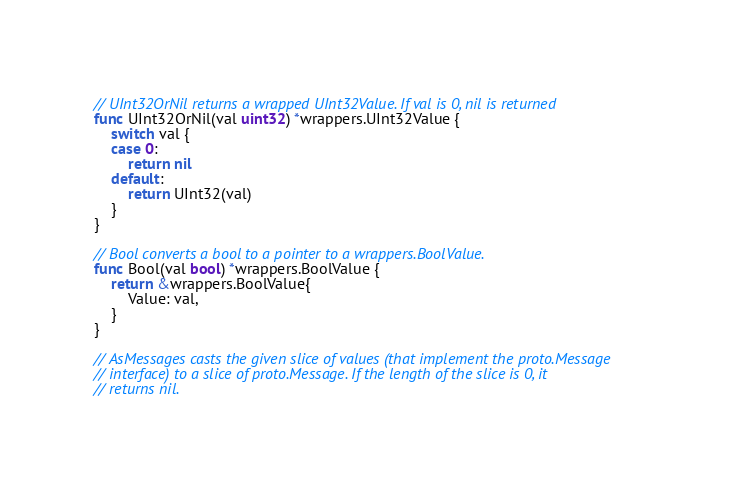Convert code to text. <code><loc_0><loc_0><loc_500><loc_500><_Go_>// UInt32OrNil returns a wrapped UInt32Value. If val is 0, nil is returned
func UInt32OrNil(val uint32) *wrappers.UInt32Value {
	switch val {
	case 0:
		return nil
	default:
		return UInt32(val)
	}
}

// Bool converts a bool to a pointer to a wrappers.BoolValue.
func Bool(val bool) *wrappers.BoolValue {
	return &wrappers.BoolValue{
		Value: val,
	}
}

// AsMessages casts the given slice of values (that implement the proto.Message
// interface) to a slice of proto.Message. If the length of the slice is 0, it
// returns nil.</code> 